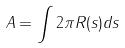Convert formula to latex. <formula><loc_0><loc_0><loc_500><loc_500>A = \int 2 \pi R ( s ) d s</formula> 